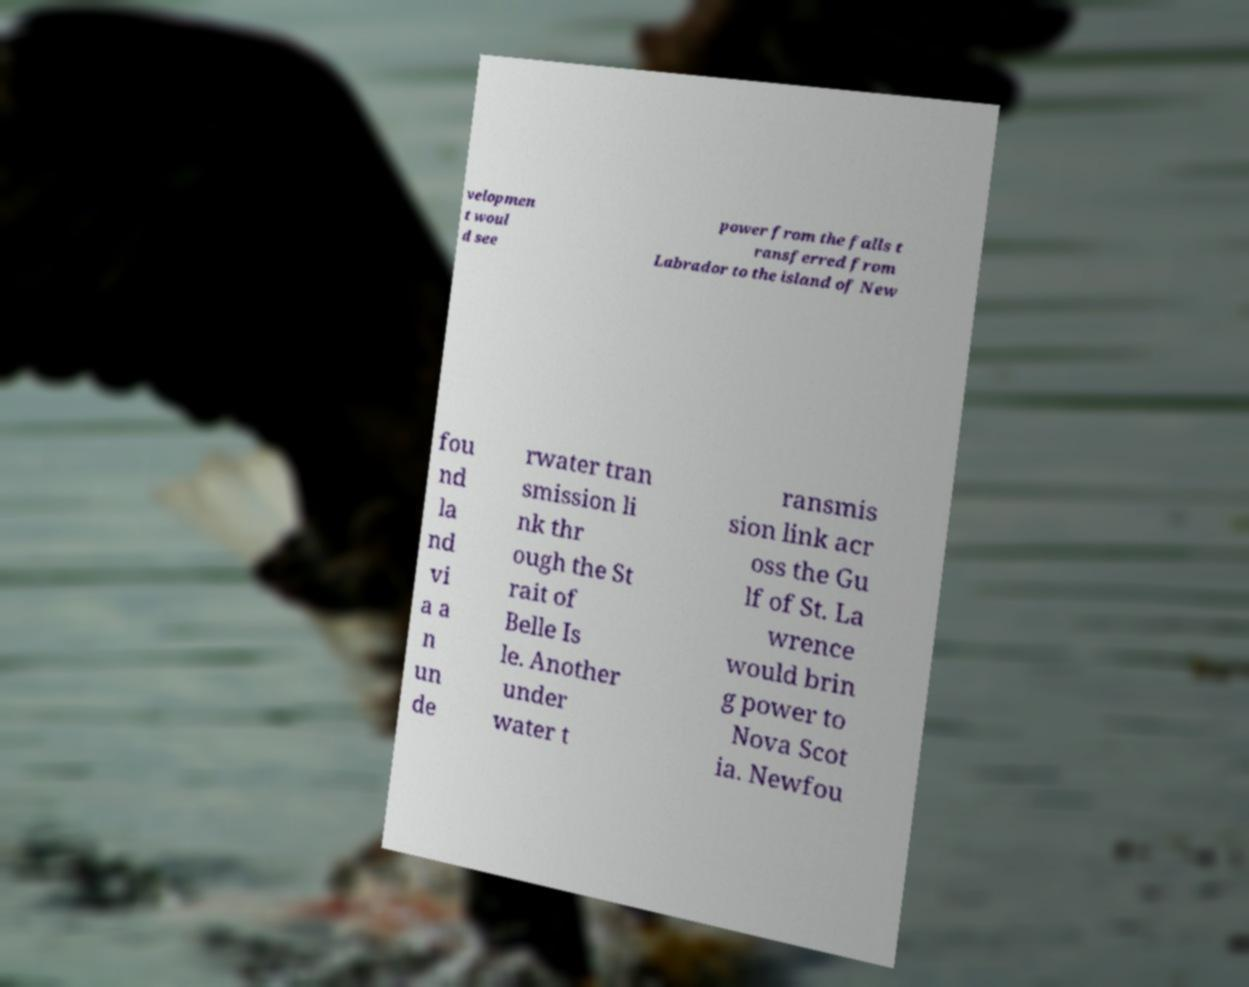I need the written content from this picture converted into text. Can you do that? velopmen t woul d see power from the falls t ransferred from Labrador to the island of New fou nd la nd vi a a n un de rwater tran smission li nk thr ough the St rait of Belle Is le. Another under water t ransmis sion link acr oss the Gu lf of St. La wrence would brin g power to Nova Scot ia. Newfou 